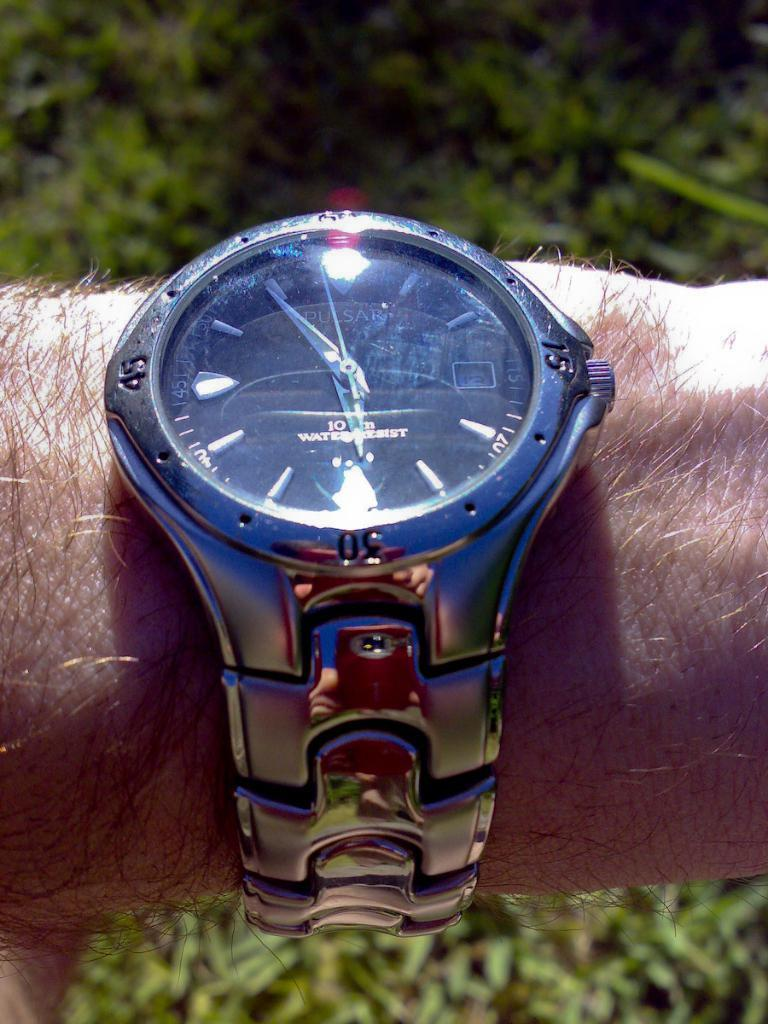<image>
Share a concise interpretation of the image provided. A silver Pulsar watch is on a man's wrist. 